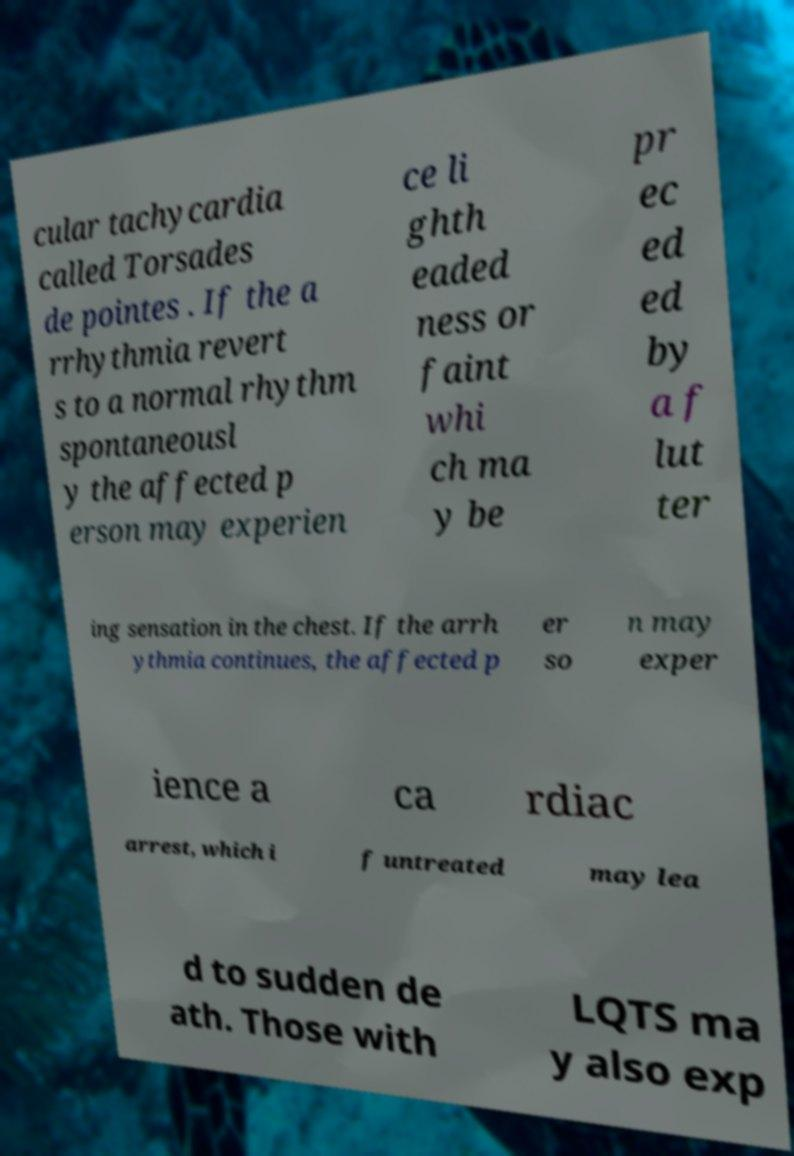Could you assist in decoding the text presented in this image and type it out clearly? cular tachycardia called Torsades de pointes . If the a rrhythmia revert s to a normal rhythm spontaneousl y the affected p erson may experien ce li ghth eaded ness or faint whi ch ma y be pr ec ed ed by a f lut ter ing sensation in the chest. If the arrh ythmia continues, the affected p er so n may exper ience a ca rdiac arrest, which i f untreated may lea d to sudden de ath. Those with LQTS ma y also exp 